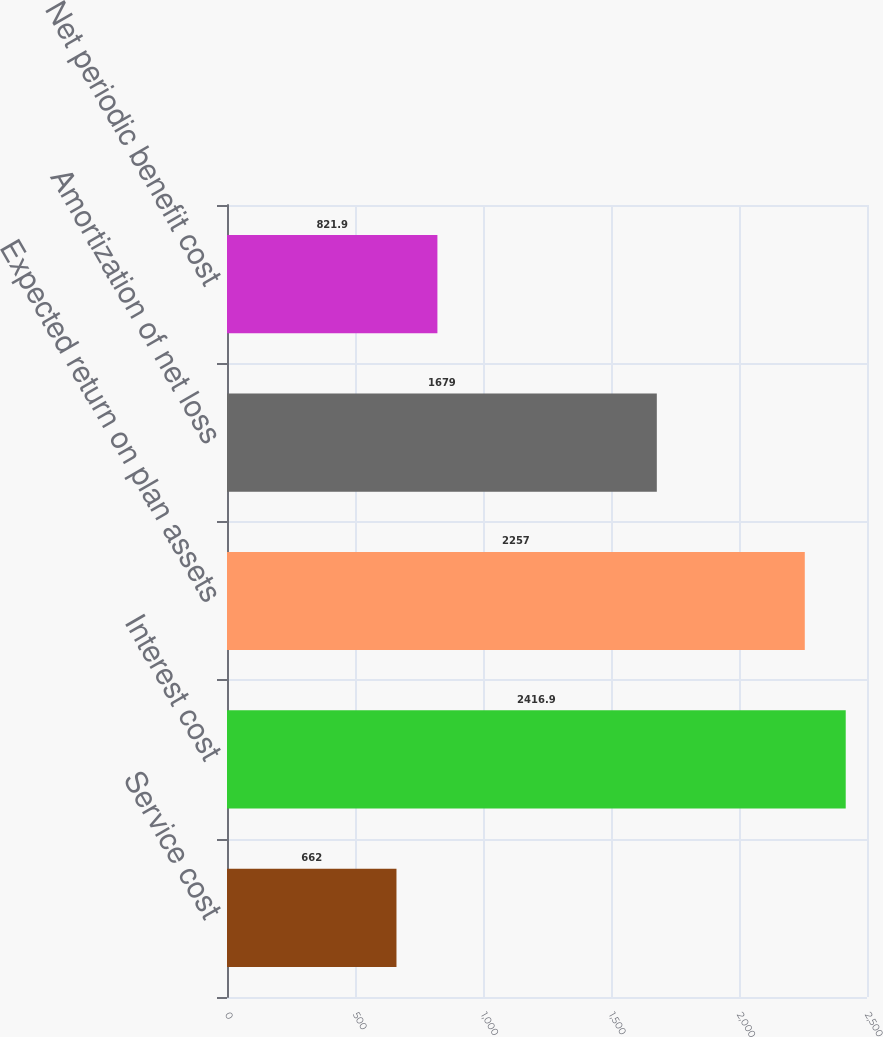Convert chart. <chart><loc_0><loc_0><loc_500><loc_500><bar_chart><fcel>Service cost<fcel>Interest cost<fcel>Expected return on plan assets<fcel>Amortization of net loss<fcel>Net periodic benefit cost<nl><fcel>662<fcel>2416.9<fcel>2257<fcel>1679<fcel>821.9<nl></chart> 